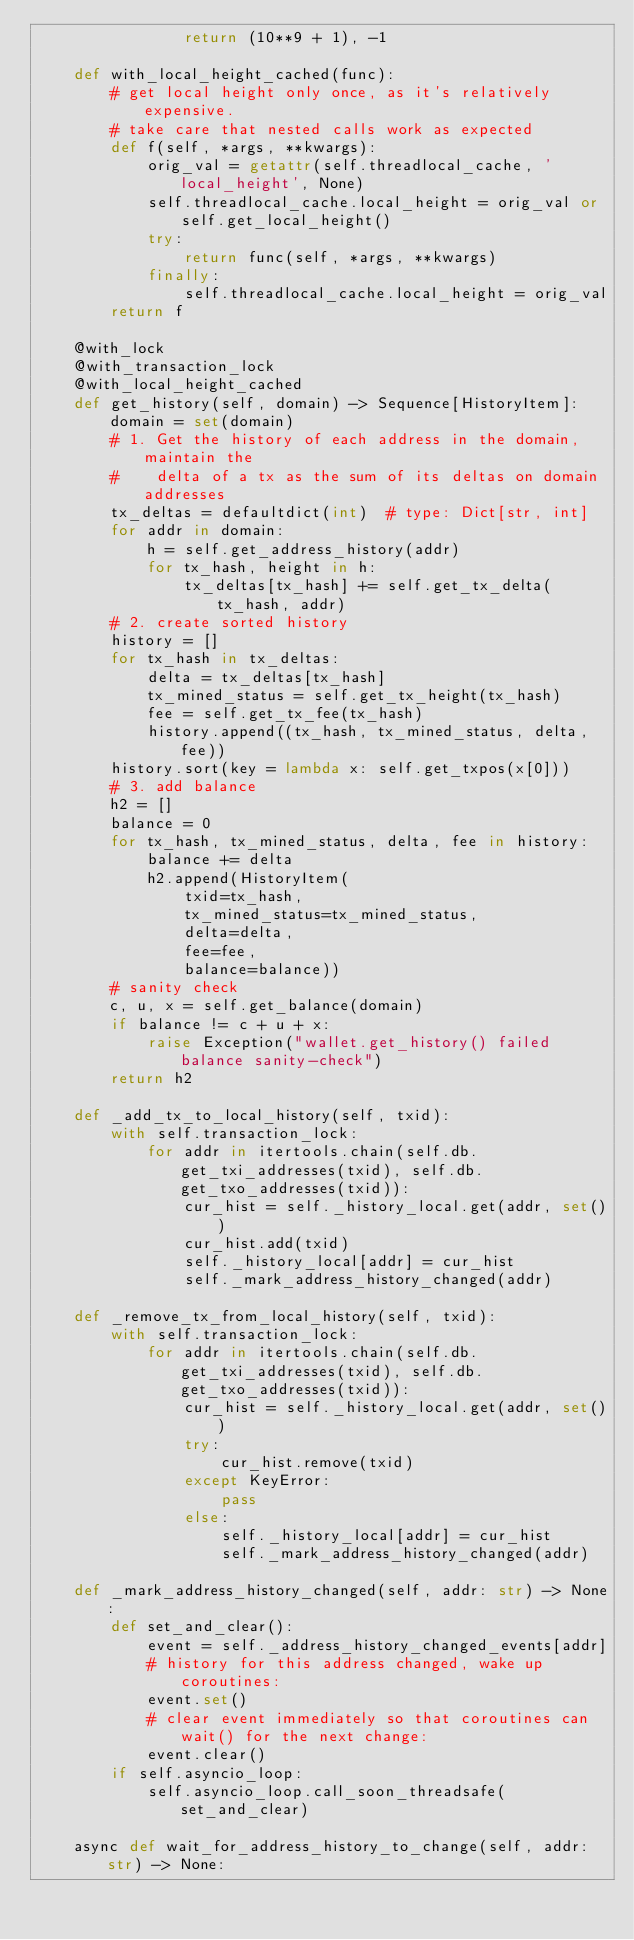Convert code to text. <code><loc_0><loc_0><loc_500><loc_500><_Python_>                return (10**9 + 1), -1

    def with_local_height_cached(func):
        # get local height only once, as it's relatively expensive.
        # take care that nested calls work as expected
        def f(self, *args, **kwargs):
            orig_val = getattr(self.threadlocal_cache, 'local_height', None)
            self.threadlocal_cache.local_height = orig_val or self.get_local_height()
            try:
                return func(self, *args, **kwargs)
            finally:
                self.threadlocal_cache.local_height = orig_val
        return f

    @with_lock
    @with_transaction_lock
    @with_local_height_cached
    def get_history(self, domain) -> Sequence[HistoryItem]:
        domain = set(domain)
        # 1. Get the history of each address in the domain, maintain the
        #    delta of a tx as the sum of its deltas on domain addresses
        tx_deltas = defaultdict(int)  # type: Dict[str, int]
        for addr in domain:
            h = self.get_address_history(addr)
            for tx_hash, height in h:
                tx_deltas[tx_hash] += self.get_tx_delta(tx_hash, addr)
        # 2. create sorted history
        history = []
        for tx_hash in tx_deltas:
            delta = tx_deltas[tx_hash]
            tx_mined_status = self.get_tx_height(tx_hash)
            fee = self.get_tx_fee(tx_hash)
            history.append((tx_hash, tx_mined_status, delta, fee))
        history.sort(key = lambda x: self.get_txpos(x[0]))
        # 3. add balance
        h2 = []
        balance = 0
        for tx_hash, tx_mined_status, delta, fee in history:
            balance += delta
            h2.append(HistoryItem(
                txid=tx_hash,
                tx_mined_status=tx_mined_status,
                delta=delta,
                fee=fee,
                balance=balance))
        # sanity check
        c, u, x = self.get_balance(domain)
        if balance != c + u + x:
            raise Exception("wallet.get_history() failed balance sanity-check")
        return h2

    def _add_tx_to_local_history(self, txid):
        with self.transaction_lock:
            for addr in itertools.chain(self.db.get_txi_addresses(txid), self.db.get_txo_addresses(txid)):
                cur_hist = self._history_local.get(addr, set())
                cur_hist.add(txid)
                self._history_local[addr] = cur_hist
                self._mark_address_history_changed(addr)

    def _remove_tx_from_local_history(self, txid):
        with self.transaction_lock:
            for addr in itertools.chain(self.db.get_txi_addresses(txid), self.db.get_txo_addresses(txid)):
                cur_hist = self._history_local.get(addr, set())
                try:
                    cur_hist.remove(txid)
                except KeyError:
                    pass
                else:
                    self._history_local[addr] = cur_hist
                    self._mark_address_history_changed(addr)

    def _mark_address_history_changed(self, addr: str) -> None:
        def set_and_clear():
            event = self._address_history_changed_events[addr]
            # history for this address changed, wake up coroutines:
            event.set()
            # clear event immediately so that coroutines can wait() for the next change:
            event.clear()
        if self.asyncio_loop:
            self.asyncio_loop.call_soon_threadsafe(set_and_clear)

    async def wait_for_address_history_to_change(self, addr: str) -> None:</code> 